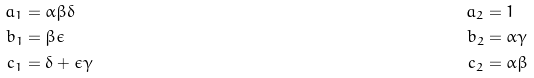Convert formula to latex. <formula><loc_0><loc_0><loc_500><loc_500>a _ { 1 } & = \alpha \beta \delta & a _ { 2 } & = 1 \\ b _ { 1 } & = \beta \epsilon & b _ { 2 } & = \alpha \gamma \\ c _ { 1 } & = \delta + \epsilon \gamma & c _ { 2 } & = \alpha \beta</formula> 